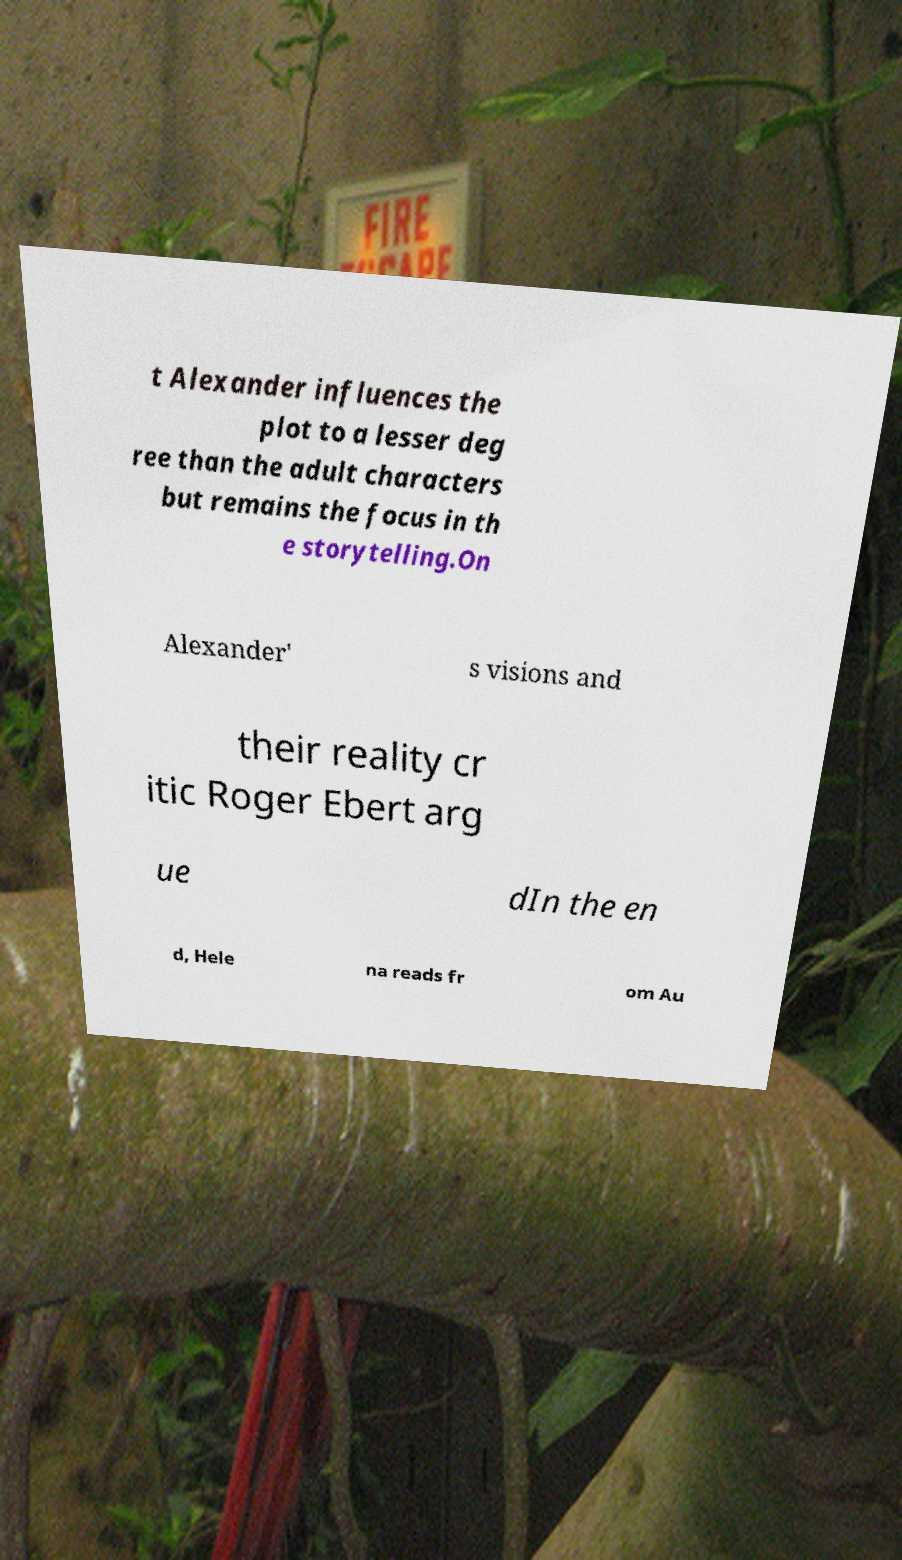For documentation purposes, I need the text within this image transcribed. Could you provide that? t Alexander influences the plot to a lesser deg ree than the adult characters but remains the focus in th e storytelling.On Alexander' s visions and their reality cr itic Roger Ebert arg ue dIn the en d, Hele na reads fr om Au 